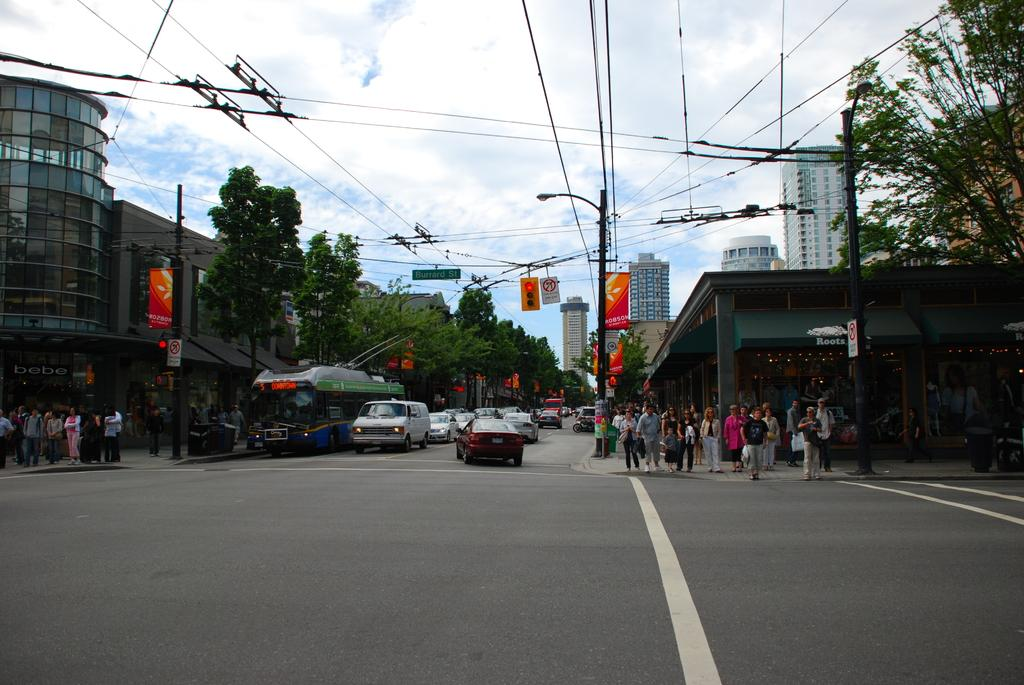What can be seen in the background of the image? There is a sky with clouds and traffic signals in the background of the image. What is happening on the road in the image? There are people on either side of the road and vehicles on the road in the image. What type of wool is being used to make the shoes in the image? There are no shoes present in the image, so it is not possible to determine the type of wool being used. 